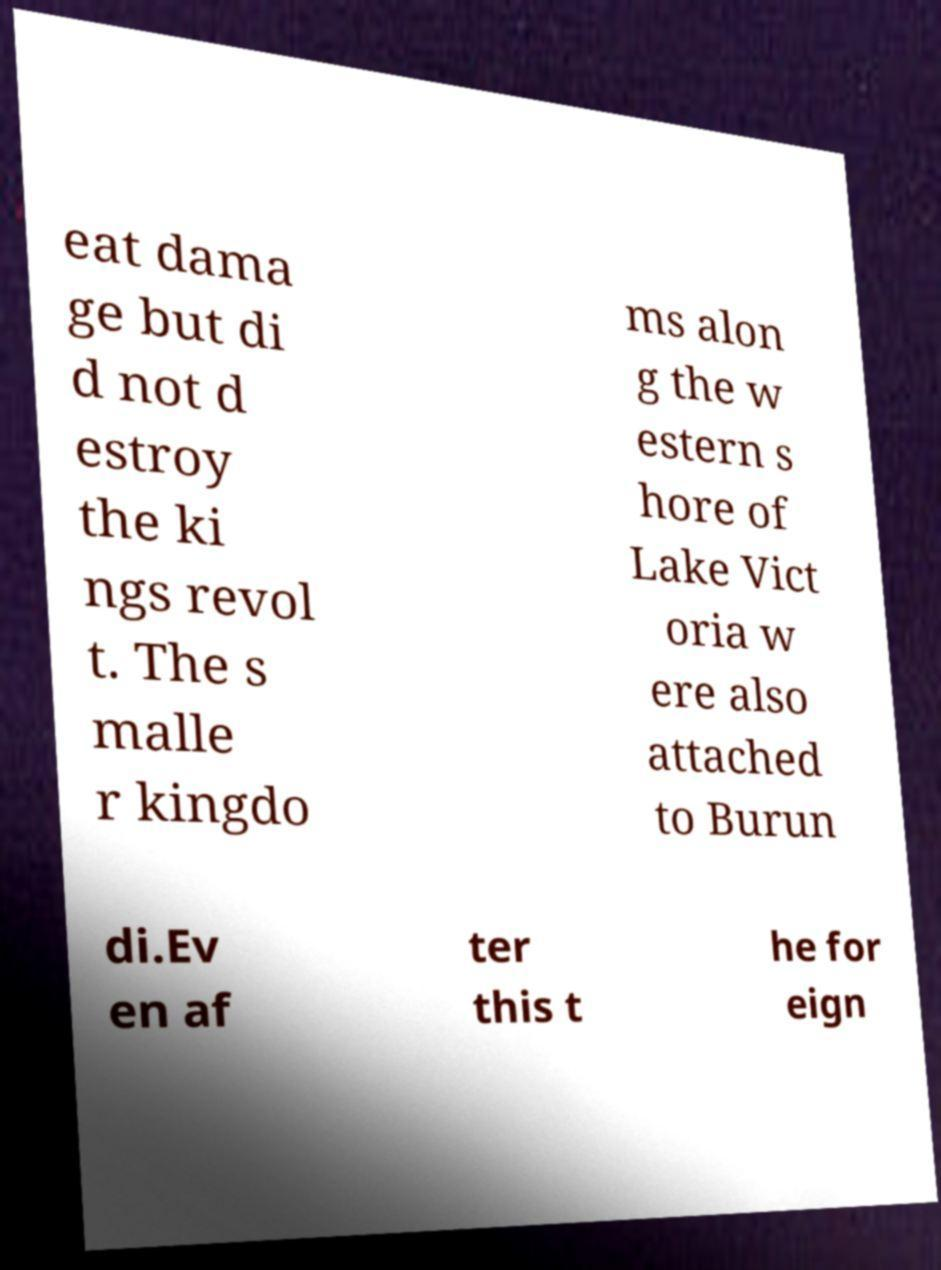For documentation purposes, I need the text within this image transcribed. Could you provide that? eat dama ge but di d not d estroy the ki ngs revol t. The s malle r kingdo ms alon g the w estern s hore of Lake Vict oria w ere also attached to Burun di.Ev en af ter this t he for eign 